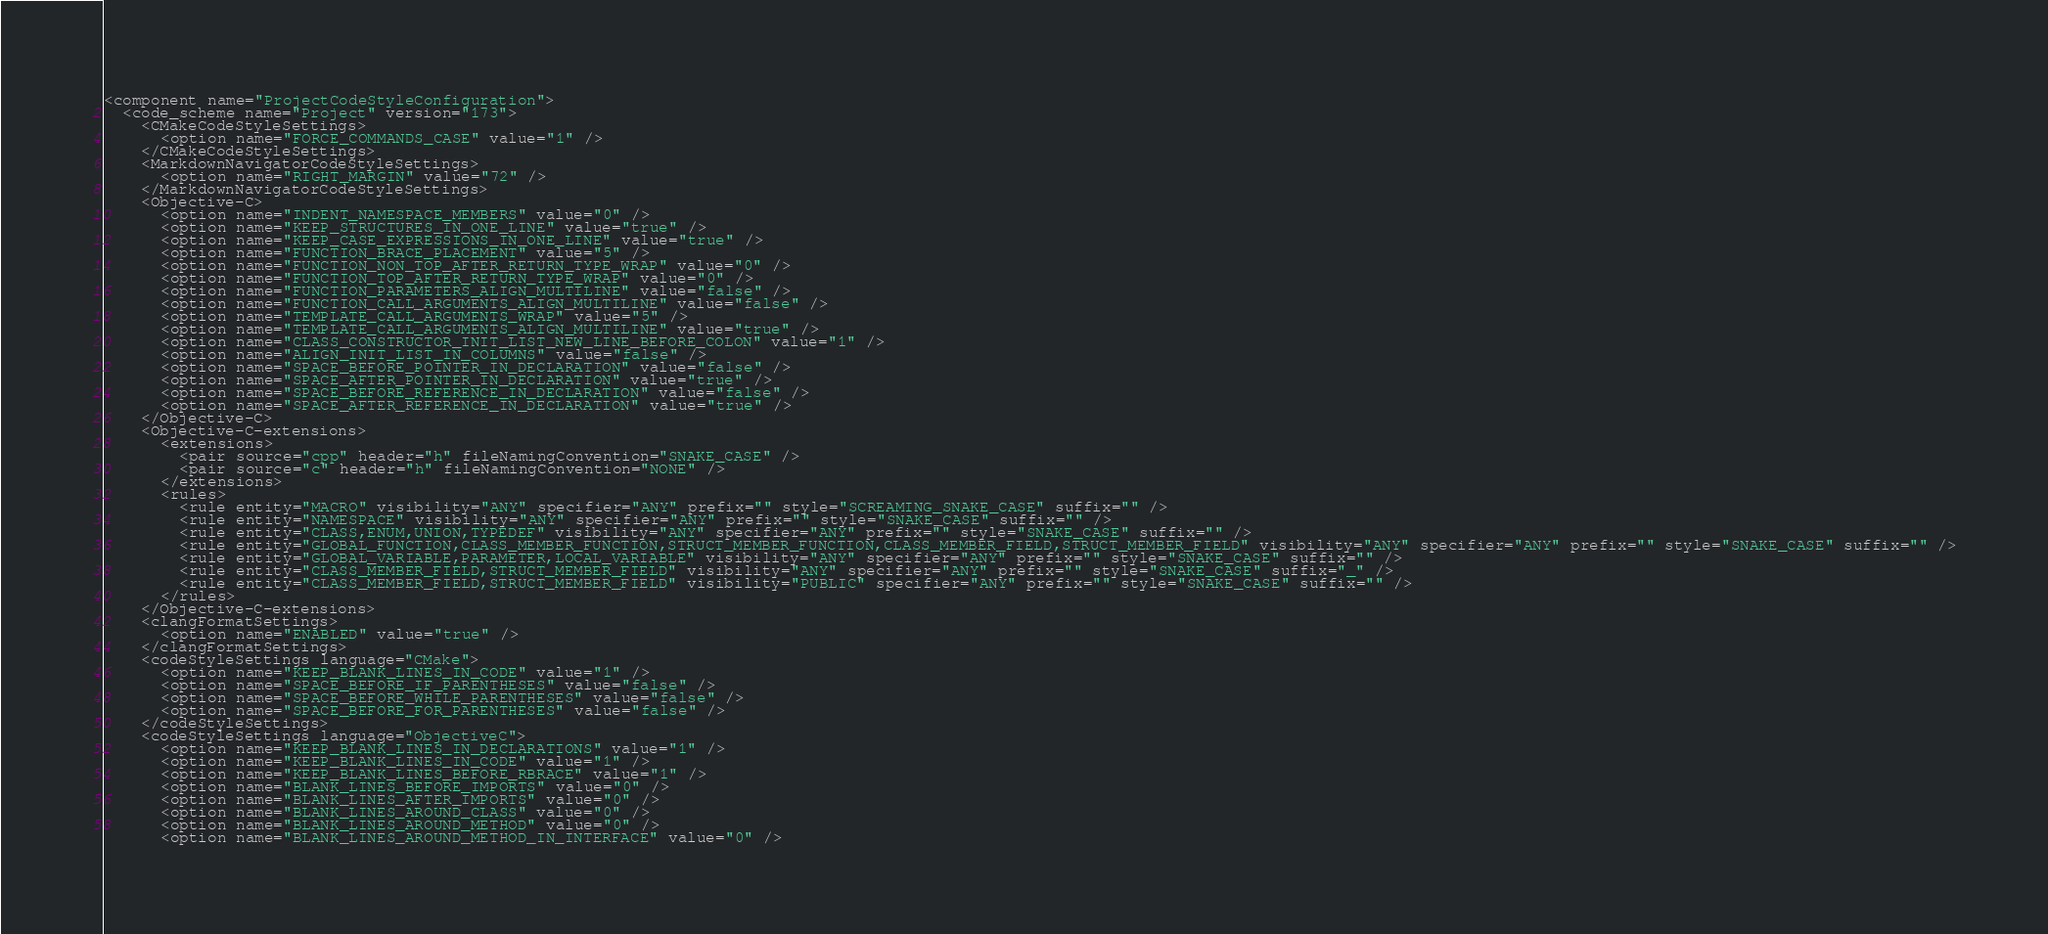Convert code to text. <code><loc_0><loc_0><loc_500><loc_500><_XML_><component name="ProjectCodeStyleConfiguration">
  <code_scheme name="Project" version="173">
    <CMakeCodeStyleSettings>
      <option name="FORCE_COMMANDS_CASE" value="1" />
    </CMakeCodeStyleSettings>
    <MarkdownNavigatorCodeStyleSettings>
      <option name="RIGHT_MARGIN" value="72" />
    </MarkdownNavigatorCodeStyleSettings>
    <Objective-C>
      <option name="INDENT_NAMESPACE_MEMBERS" value="0" />
      <option name="KEEP_STRUCTURES_IN_ONE_LINE" value="true" />
      <option name="KEEP_CASE_EXPRESSIONS_IN_ONE_LINE" value="true" />
      <option name="FUNCTION_BRACE_PLACEMENT" value="5" />
      <option name="FUNCTION_NON_TOP_AFTER_RETURN_TYPE_WRAP" value="0" />
      <option name="FUNCTION_TOP_AFTER_RETURN_TYPE_WRAP" value="0" />
      <option name="FUNCTION_PARAMETERS_ALIGN_MULTILINE" value="false" />
      <option name="FUNCTION_CALL_ARGUMENTS_ALIGN_MULTILINE" value="false" />
      <option name="TEMPLATE_CALL_ARGUMENTS_WRAP" value="5" />
      <option name="TEMPLATE_CALL_ARGUMENTS_ALIGN_MULTILINE" value="true" />
      <option name="CLASS_CONSTRUCTOR_INIT_LIST_NEW_LINE_BEFORE_COLON" value="1" />
      <option name="ALIGN_INIT_LIST_IN_COLUMNS" value="false" />
      <option name="SPACE_BEFORE_POINTER_IN_DECLARATION" value="false" />
      <option name="SPACE_AFTER_POINTER_IN_DECLARATION" value="true" />
      <option name="SPACE_BEFORE_REFERENCE_IN_DECLARATION" value="false" />
      <option name="SPACE_AFTER_REFERENCE_IN_DECLARATION" value="true" />
    </Objective-C>
    <Objective-C-extensions>
      <extensions>
        <pair source="cpp" header="h" fileNamingConvention="SNAKE_CASE" />
        <pair source="c" header="h" fileNamingConvention="NONE" />
      </extensions>
      <rules>
        <rule entity="MACRO" visibility="ANY" specifier="ANY" prefix="" style="SCREAMING_SNAKE_CASE" suffix="" />
        <rule entity="NAMESPACE" visibility="ANY" specifier="ANY" prefix="" style="SNAKE_CASE" suffix="" />
        <rule entity="CLASS,ENUM,UNION,TYPEDEF" visibility="ANY" specifier="ANY" prefix="" style="SNAKE_CASE" suffix="" />
        <rule entity="GLOBAL_FUNCTION,CLASS_MEMBER_FUNCTION,STRUCT_MEMBER_FUNCTION,CLASS_MEMBER_FIELD,STRUCT_MEMBER_FIELD" visibility="ANY" specifier="ANY" prefix="" style="SNAKE_CASE" suffix="" />
        <rule entity="GLOBAL_VARIABLE,PARAMETER,LOCAL_VARIABLE" visibility="ANY" specifier="ANY" prefix="" style="SNAKE_CASE" suffix="" />
        <rule entity="CLASS_MEMBER_FIELD,STRUCT_MEMBER_FIELD" visibility="ANY" specifier="ANY" prefix="" style="SNAKE_CASE" suffix="_" />
        <rule entity="CLASS_MEMBER_FIELD,STRUCT_MEMBER_FIELD" visibility="PUBLIC" specifier="ANY" prefix="" style="SNAKE_CASE" suffix="" />
      </rules>
    </Objective-C-extensions>
    <clangFormatSettings>
      <option name="ENABLED" value="true" />
    </clangFormatSettings>
    <codeStyleSettings language="CMake">
      <option name="KEEP_BLANK_LINES_IN_CODE" value="1" />
      <option name="SPACE_BEFORE_IF_PARENTHESES" value="false" />
      <option name="SPACE_BEFORE_WHILE_PARENTHESES" value="false" />
      <option name="SPACE_BEFORE_FOR_PARENTHESES" value="false" />
    </codeStyleSettings>
    <codeStyleSettings language="ObjectiveC">
      <option name="KEEP_BLANK_LINES_IN_DECLARATIONS" value="1" />
      <option name="KEEP_BLANK_LINES_IN_CODE" value="1" />
      <option name="KEEP_BLANK_LINES_BEFORE_RBRACE" value="1" />
      <option name="BLANK_LINES_BEFORE_IMPORTS" value="0" />
      <option name="BLANK_LINES_AFTER_IMPORTS" value="0" />
      <option name="BLANK_LINES_AROUND_CLASS" value="0" />
      <option name="BLANK_LINES_AROUND_METHOD" value="0" />
      <option name="BLANK_LINES_AROUND_METHOD_IN_INTERFACE" value="0" /></code> 